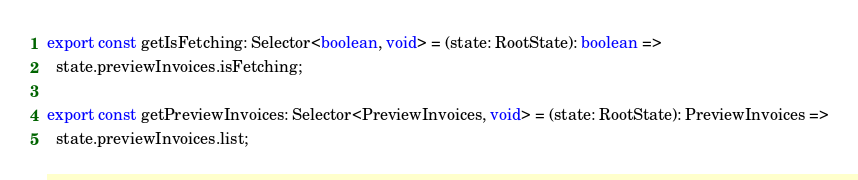<code> <loc_0><loc_0><loc_500><loc_500><_JavaScript_>
export const getIsFetching: Selector<boolean, void> = (state: RootState): boolean =>
  state.previewInvoices.isFetching;

export const getPreviewInvoices: Selector<PreviewInvoices, void> = (state: RootState): PreviewInvoices =>
  state.previewInvoices.list;
</code> 